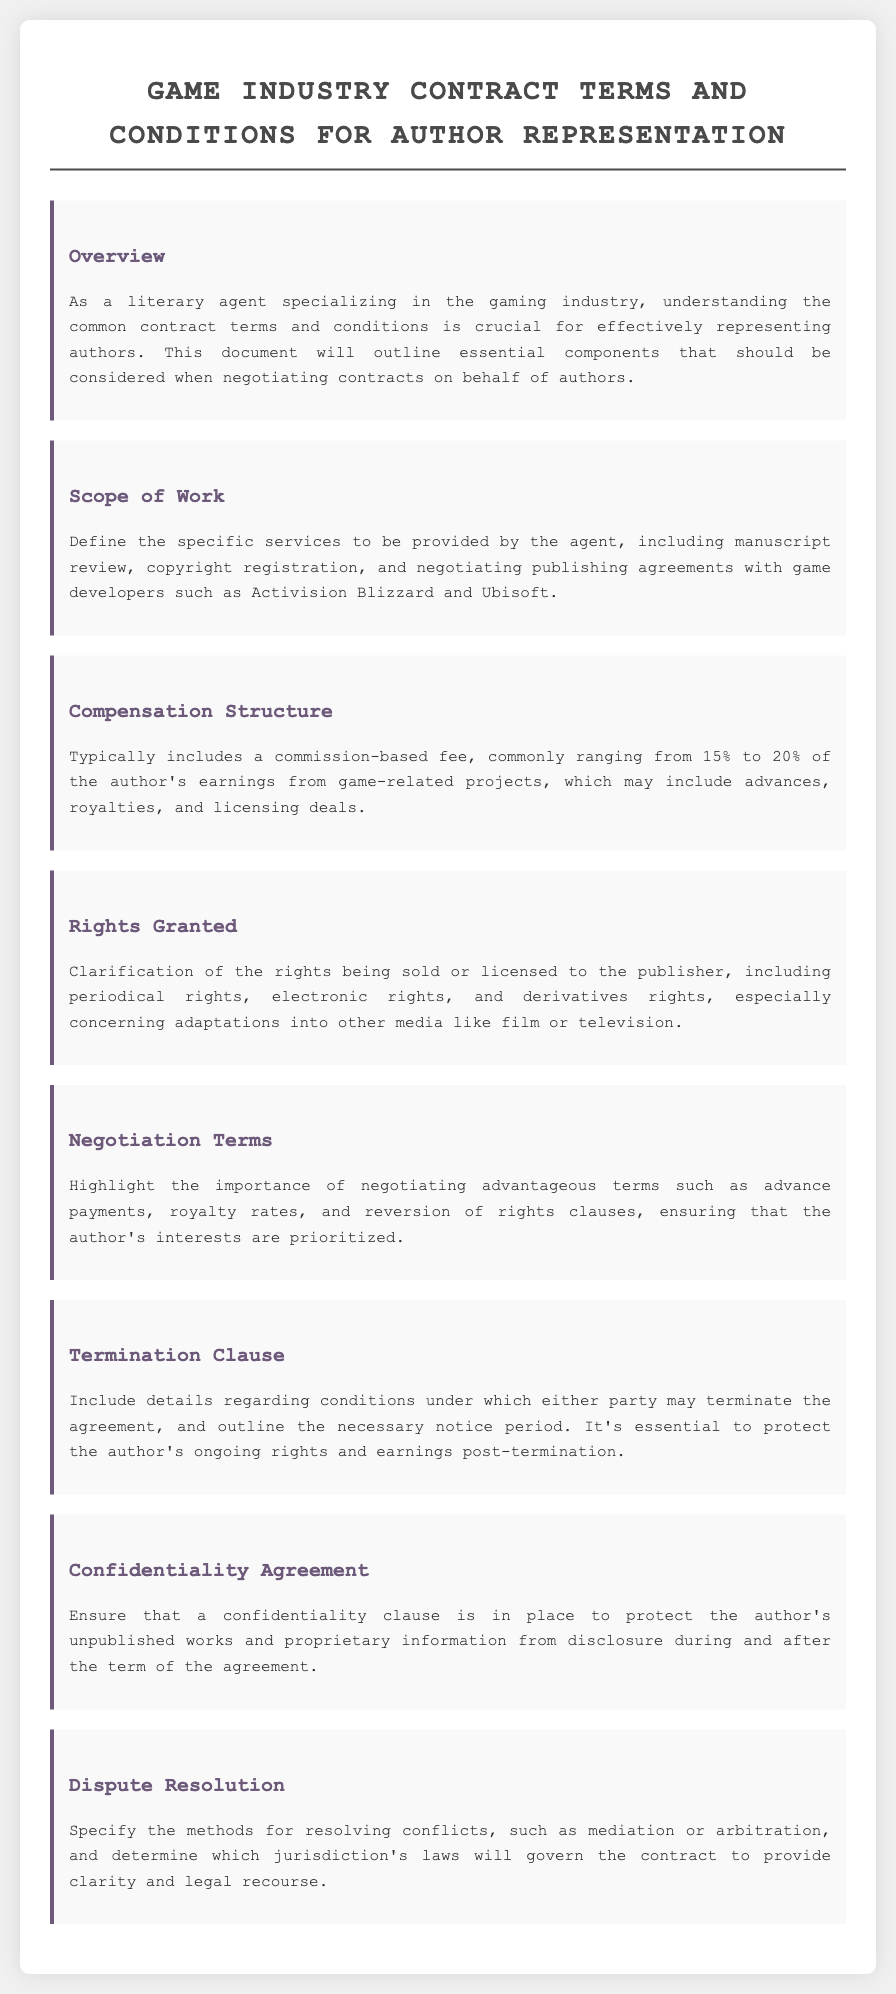What is the commission range for agent compensation? The compensation structure typically includes a commission-based fee, commonly ranging from 15% to 20%.
Answer: 15% to 20% What rights are clarified in the 'Rights Granted' section? The rights granted section clarifies specific rights being sold or licensed to the publisher, including periodical rights, electronic rights, and derivatives rights.
Answer: Periodical rights, electronic rights, derivatives rights What is the purpose of the confidentiality agreement? The confidentiality agreement is in place to protect the author's unpublished works and proprietary information from disclosure.
Answer: Protect the author's unpublished works What are the two methods suggested for dispute resolution? The dispute resolution section specifies methods for resolving conflicts, such as mediation or arbitration.
Answer: Mediation, arbitration What percentage of the author's earnings does the agent typically earn? The compensation structure states that the agent's fee is commonly a percentage of the author's earnings from game-related projects.
Answer: 15% to 20% What clause protects the author’s rights post-termination? The termination clause includes details regarding ongoing rights and earnings post-termination to protect the author.
Answer: Protect the author's ongoing rights What should be included in the 'Negotiation Terms' section? The negotiation terms should highlight advantageous terms such as advance payments, royalty rates, and reversion of rights clauses.
Answer: Advance payments, royalty rates, reversion of rights clauses Which companies are mentioned as examples for negotiating publishing agreements? The 'Scope of Work' section mentions specific game developers such as Activision Blizzard and Ubisoft for negotiating publishing agreements.
Answer: Activision Blizzard, Ubisoft 